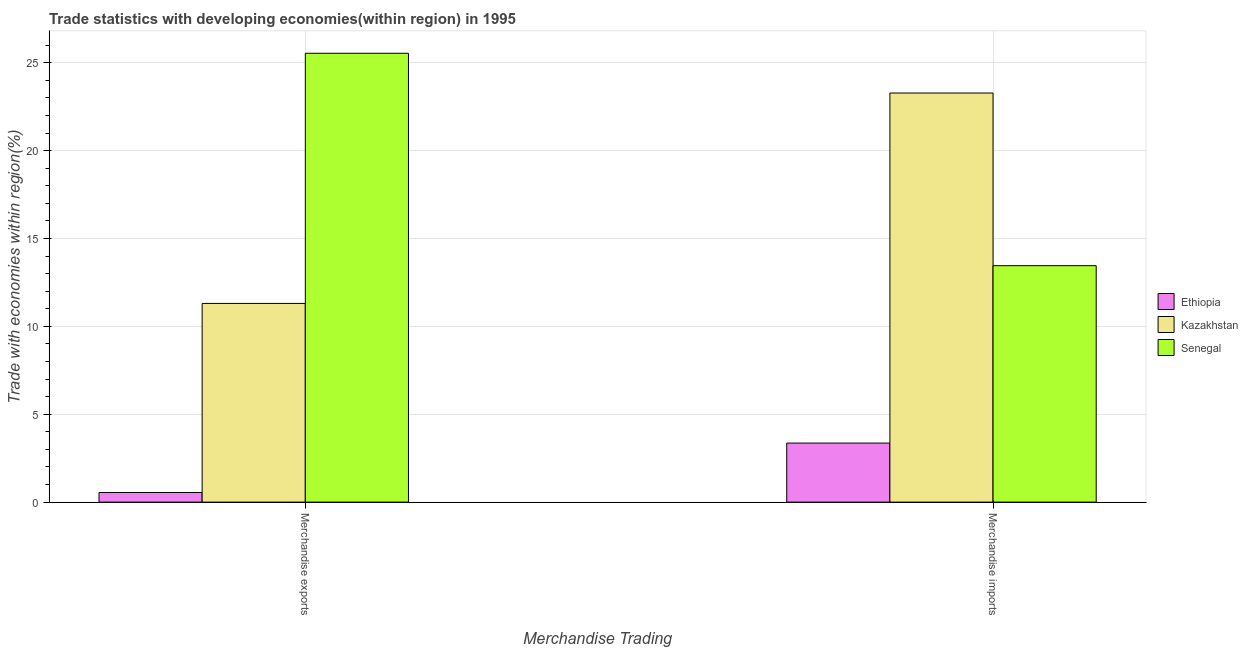How many different coloured bars are there?
Make the answer very short. 3. How many groups of bars are there?
Make the answer very short. 2. How many bars are there on the 2nd tick from the right?
Make the answer very short. 3. What is the merchandise exports in Kazakhstan?
Provide a succinct answer. 11.31. Across all countries, what is the maximum merchandise exports?
Provide a succinct answer. 25.54. Across all countries, what is the minimum merchandise exports?
Keep it short and to the point. 0.55. In which country was the merchandise imports maximum?
Make the answer very short. Kazakhstan. In which country was the merchandise imports minimum?
Give a very brief answer. Ethiopia. What is the total merchandise exports in the graph?
Ensure brevity in your answer.  37.4. What is the difference between the merchandise exports in Kazakhstan and that in Senegal?
Your answer should be compact. -14.24. What is the difference between the merchandise exports in Kazakhstan and the merchandise imports in Senegal?
Give a very brief answer. -2.15. What is the average merchandise exports per country?
Offer a very short reply. 12.47. What is the difference between the merchandise imports and merchandise exports in Senegal?
Your answer should be compact. -12.09. In how many countries, is the merchandise imports greater than 14 %?
Your answer should be very brief. 1. What is the ratio of the merchandise imports in Kazakhstan to that in Senegal?
Offer a very short reply. 1.73. Is the merchandise exports in Senegal less than that in Ethiopia?
Offer a very short reply. No. What does the 3rd bar from the left in Merchandise imports represents?
Your answer should be very brief. Senegal. What does the 1st bar from the right in Merchandise exports represents?
Provide a succinct answer. Senegal. How many bars are there?
Your answer should be compact. 6. How many countries are there in the graph?
Give a very brief answer. 3. Are the values on the major ticks of Y-axis written in scientific E-notation?
Your answer should be compact. No. Does the graph contain any zero values?
Offer a terse response. No. What is the title of the graph?
Keep it short and to the point. Trade statistics with developing economies(within region) in 1995. What is the label or title of the X-axis?
Your answer should be compact. Merchandise Trading. What is the label or title of the Y-axis?
Provide a short and direct response. Trade with economies within region(%). What is the Trade with economies within region(%) of Ethiopia in Merchandise exports?
Provide a short and direct response. 0.55. What is the Trade with economies within region(%) of Kazakhstan in Merchandise exports?
Your answer should be very brief. 11.31. What is the Trade with economies within region(%) in Senegal in Merchandise exports?
Your response must be concise. 25.54. What is the Trade with economies within region(%) of Ethiopia in Merchandise imports?
Offer a very short reply. 3.36. What is the Trade with economies within region(%) in Kazakhstan in Merchandise imports?
Give a very brief answer. 23.28. What is the Trade with economies within region(%) in Senegal in Merchandise imports?
Provide a succinct answer. 13.46. Across all Merchandise Trading, what is the maximum Trade with economies within region(%) of Ethiopia?
Provide a succinct answer. 3.36. Across all Merchandise Trading, what is the maximum Trade with economies within region(%) in Kazakhstan?
Provide a short and direct response. 23.28. Across all Merchandise Trading, what is the maximum Trade with economies within region(%) in Senegal?
Offer a very short reply. 25.54. Across all Merchandise Trading, what is the minimum Trade with economies within region(%) in Ethiopia?
Your answer should be compact. 0.55. Across all Merchandise Trading, what is the minimum Trade with economies within region(%) of Kazakhstan?
Keep it short and to the point. 11.31. Across all Merchandise Trading, what is the minimum Trade with economies within region(%) of Senegal?
Offer a very short reply. 13.46. What is the total Trade with economies within region(%) in Ethiopia in the graph?
Give a very brief answer. 3.91. What is the total Trade with economies within region(%) of Kazakhstan in the graph?
Offer a very short reply. 34.59. What is the total Trade with economies within region(%) in Senegal in the graph?
Ensure brevity in your answer.  39. What is the difference between the Trade with economies within region(%) of Ethiopia in Merchandise exports and that in Merchandise imports?
Your answer should be very brief. -2.81. What is the difference between the Trade with economies within region(%) in Kazakhstan in Merchandise exports and that in Merchandise imports?
Provide a succinct answer. -11.97. What is the difference between the Trade with economies within region(%) in Senegal in Merchandise exports and that in Merchandise imports?
Make the answer very short. 12.09. What is the difference between the Trade with economies within region(%) of Ethiopia in Merchandise exports and the Trade with economies within region(%) of Kazakhstan in Merchandise imports?
Your answer should be very brief. -22.73. What is the difference between the Trade with economies within region(%) in Ethiopia in Merchandise exports and the Trade with economies within region(%) in Senegal in Merchandise imports?
Your answer should be compact. -12.91. What is the difference between the Trade with economies within region(%) in Kazakhstan in Merchandise exports and the Trade with economies within region(%) in Senegal in Merchandise imports?
Offer a very short reply. -2.15. What is the average Trade with economies within region(%) in Ethiopia per Merchandise Trading?
Provide a short and direct response. 1.95. What is the average Trade with economies within region(%) in Kazakhstan per Merchandise Trading?
Your answer should be very brief. 17.29. What is the average Trade with economies within region(%) of Senegal per Merchandise Trading?
Ensure brevity in your answer.  19.5. What is the difference between the Trade with economies within region(%) of Ethiopia and Trade with economies within region(%) of Kazakhstan in Merchandise exports?
Offer a very short reply. -10.76. What is the difference between the Trade with economies within region(%) of Ethiopia and Trade with economies within region(%) of Senegal in Merchandise exports?
Offer a very short reply. -25. What is the difference between the Trade with economies within region(%) of Kazakhstan and Trade with economies within region(%) of Senegal in Merchandise exports?
Offer a very short reply. -14.24. What is the difference between the Trade with economies within region(%) in Ethiopia and Trade with economies within region(%) in Kazakhstan in Merchandise imports?
Provide a short and direct response. -19.92. What is the difference between the Trade with economies within region(%) in Ethiopia and Trade with economies within region(%) in Senegal in Merchandise imports?
Make the answer very short. -10.1. What is the difference between the Trade with economies within region(%) of Kazakhstan and Trade with economies within region(%) of Senegal in Merchandise imports?
Keep it short and to the point. 9.83. What is the ratio of the Trade with economies within region(%) in Ethiopia in Merchandise exports to that in Merchandise imports?
Offer a terse response. 0.16. What is the ratio of the Trade with economies within region(%) in Kazakhstan in Merchandise exports to that in Merchandise imports?
Offer a terse response. 0.49. What is the ratio of the Trade with economies within region(%) in Senegal in Merchandise exports to that in Merchandise imports?
Keep it short and to the point. 1.9. What is the difference between the highest and the second highest Trade with economies within region(%) of Ethiopia?
Provide a short and direct response. 2.81. What is the difference between the highest and the second highest Trade with economies within region(%) in Kazakhstan?
Keep it short and to the point. 11.97. What is the difference between the highest and the second highest Trade with economies within region(%) in Senegal?
Your answer should be compact. 12.09. What is the difference between the highest and the lowest Trade with economies within region(%) in Ethiopia?
Give a very brief answer. 2.81. What is the difference between the highest and the lowest Trade with economies within region(%) in Kazakhstan?
Provide a short and direct response. 11.97. What is the difference between the highest and the lowest Trade with economies within region(%) in Senegal?
Offer a very short reply. 12.09. 